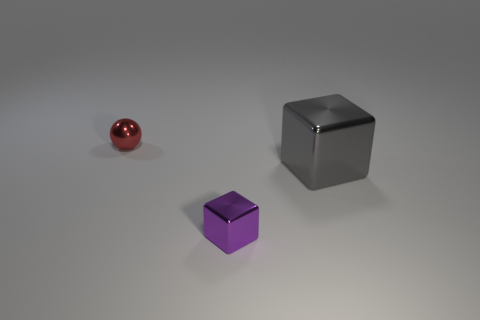Does the large gray cube have the same material as the small purple thing?
Your answer should be very brief. Yes. What is the shape of the thing that is the same size as the sphere?
Give a very brief answer. Cube. Are there more small matte blocks than tiny purple things?
Ensure brevity in your answer.  No. What is the material of the thing that is behind the purple shiny cube and left of the gray cube?
Offer a very short reply. Metal. How many other things are there of the same material as the purple thing?
Your response must be concise. 2. What number of tiny objects have the same color as the big shiny object?
Keep it short and to the point. 0. What size is the gray metallic cube to the right of the small shiny thing on the right side of the metal thing that is on the left side of the tiny purple shiny object?
Give a very brief answer. Large. How many matte objects are either small purple cubes or red cylinders?
Your answer should be compact. 0. Is the shape of the tiny red metallic object the same as the thing that is on the right side of the tiny block?
Your answer should be compact. No. Is the number of red balls in front of the small block greater than the number of small metal objects that are in front of the large block?
Offer a very short reply. No. 